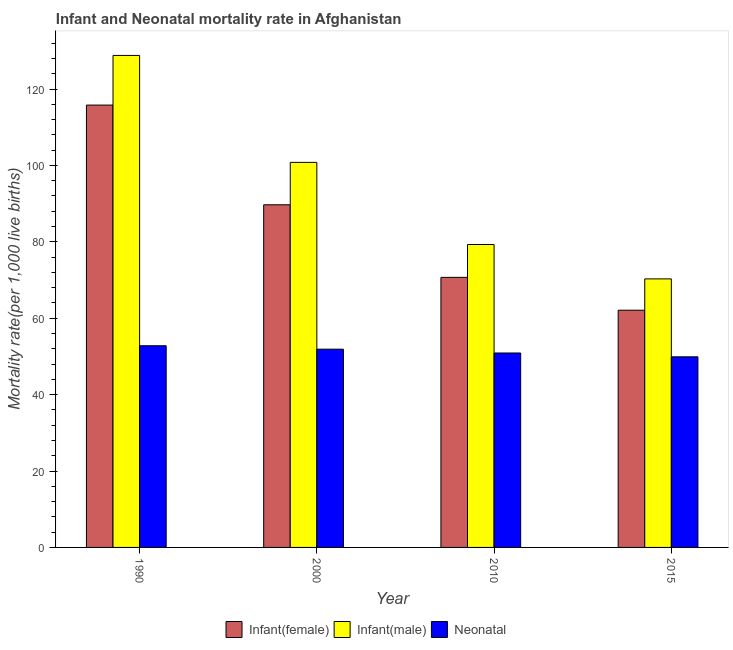How many bars are there on the 3rd tick from the right?
Your response must be concise. 3. What is the label of the 2nd group of bars from the left?
Ensure brevity in your answer.  2000. In how many cases, is the number of bars for a given year not equal to the number of legend labels?
Give a very brief answer. 0. What is the neonatal mortality rate in 2015?
Your answer should be compact. 49.9. Across all years, what is the maximum infant mortality rate(female)?
Keep it short and to the point. 115.8. Across all years, what is the minimum infant mortality rate(male)?
Keep it short and to the point. 70.3. In which year was the neonatal mortality rate maximum?
Your response must be concise. 1990. In which year was the infant mortality rate(male) minimum?
Offer a terse response. 2015. What is the total infant mortality rate(female) in the graph?
Provide a succinct answer. 338.3. What is the difference between the infant mortality rate(female) in 2010 and that in 2015?
Ensure brevity in your answer.  8.6. What is the difference between the infant mortality rate(female) in 2010 and the neonatal mortality rate in 2000?
Your answer should be very brief. -19. What is the average infant mortality rate(male) per year?
Your response must be concise. 94.8. In the year 1990, what is the difference between the infant mortality rate(female) and neonatal mortality rate?
Provide a short and direct response. 0. What is the ratio of the infant mortality rate(female) in 2000 to that in 2015?
Your response must be concise. 1.44. Is the difference between the infant mortality rate(female) in 1990 and 2000 greater than the difference between the infant mortality rate(male) in 1990 and 2000?
Offer a terse response. No. What is the difference between the highest and the second highest neonatal mortality rate?
Your answer should be compact. 0.9. What is the difference between the highest and the lowest infant mortality rate(male)?
Make the answer very short. 58.5. Is the sum of the neonatal mortality rate in 1990 and 2015 greater than the maximum infant mortality rate(female) across all years?
Ensure brevity in your answer.  Yes. What does the 3rd bar from the left in 1990 represents?
Give a very brief answer. Neonatal . What does the 2nd bar from the right in 1990 represents?
Provide a succinct answer. Infant(male). Is it the case that in every year, the sum of the infant mortality rate(female) and infant mortality rate(male) is greater than the neonatal mortality rate?
Offer a terse response. Yes. How many bars are there?
Provide a short and direct response. 12. Are all the bars in the graph horizontal?
Your response must be concise. No. What is the difference between two consecutive major ticks on the Y-axis?
Offer a very short reply. 20. Are the values on the major ticks of Y-axis written in scientific E-notation?
Make the answer very short. No. How many legend labels are there?
Give a very brief answer. 3. How are the legend labels stacked?
Offer a very short reply. Horizontal. What is the title of the graph?
Your answer should be compact. Infant and Neonatal mortality rate in Afghanistan. What is the label or title of the X-axis?
Provide a short and direct response. Year. What is the label or title of the Y-axis?
Your answer should be compact. Mortality rate(per 1,0 live births). What is the Mortality rate(per 1,000 live births) of Infant(female) in 1990?
Offer a terse response. 115.8. What is the Mortality rate(per 1,000 live births) of Infant(male) in 1990?
Provide a short and direct response. 128.8. What is the Mortality rate(per 1,000 live births) in Neonatal  in 1990?
Offer a terse response. 52.8. What is the Mortality rate(per 1,000 live births) of Infant(female) in 2000?
Your response must be concise. 89.7. What is the Mortality rate(per 1,000 live births) in Infant(male) in 2000?
Provide a succinct answer. 100.8. What is the Mortality rate(per 1,000 live births) in Neonatal  in 2000?
Your answer should be very brief. 51.9. What is the Mortality rate(per 1,000 live births) in Infant(female) in 2010?
Ensure brevity in your answer.  70.7. What is the Mortality rate(per 1,000 live births) of Infant(male) in 2010?
Provide a succinct answer. 79.3. What is the Mortality rate(per 1,000 live births) in Neonatal  in 2010?
Offer a terse response. 50.9. What is the Mortality rate(per 1,000 live births) of Infant(female) in 2015?
Offer a very short reply. 62.1. What is the Mortality rate(per 1,000 live births) in Infant(male) in 2015?
Your response must be concise. 70.3. What is the Mortality rate(per 1,000 live births) in Neonatal  in 2015?
Your response must be concise. 49.9. Across all years, what is the maximum Mortality rate(per 1,000 live births) in Infant(female)?
Your answer should be very brief. 115.8. Across all years, what is the maximum Mortality rate(per 1,000 live births) in Infant(male)?
Your answer should be compact. 128.8. Across all years, what is the maximum Mortality rate(per 1,000 live births) of Neonatal ?
Offer a very short reply. 52.8. Across all years, what is the minimum Mortality rate(per 1,000 live births) of Infant(female)?
Your response must be concise. 62.1. Across all years, what is the minimum Mortality rate(per 1,000 live births) in Infant(male)?
Offer a very short reply. 70.3. Across all years, what is the minimum Mortality rate(per 1,000 live births) in Neonatal ?
Offer a very short reply. 49.9. What is the total Mortality rate(per 1,000 live births) in Infant(female) in the graph?
Make the answer very short. 338.3. What is the total Mortality rate(per 1,000 live births) of Infant(male) in the graph?
Your answer should be compact. 379.2. What is the total Mortality rate(per 1,000 live births) of Neonatal  in the graph?
Ensure brevity in your answer.  205.5. What is the difference between the Mortality rate(per 1,000 live births) of Infant(female) in 1990 and that in 2000?
Ensure brevity in your answer.  26.1. What is the difference between the Mortality rate(per 1,000 live births) of Infant(male) in 1990 and that in 2000?
Keep it short and to the point. 28. What is the difference between the Mortality rate(per 1,000 live births) in Neonatal  in 1990 and that in 2000?
Your answer should be very brief. 0.9. What is the difference between the Mortality rate(per 1,000 live births) in Infant(female) in 1990 and that in 2010?
Keep it short and to the point. 45.1. What is the difference between the Mortality rate(per 1,000 live births) of Infant(male) in 1990 and that in 2010?
Provide a short and direct response. 49.5. What is the difference between the Mortality rate(per 1,000 live births) in Infant(female) in 1990 and that in 2015?
Your answer should be very brief. 53.7. What is the difference between the Mortality rate(per 1,000 live births) of Infant(male) in 1990 and that in 2015?
Offer a very short reply. 58.5. What is the difference between the Mortality rate(per 1,000 live births) in Neonatal  in 1990 and that in 2015?
Your answer should be compact. 2.9. What is the difference between the Mortality rate(per 1,000 live births) in Infant(female) in 2000 and that in 2010?
Offer a very short reply. 19. What is the difference between the Mortality rate(per 1,000 live births) in Infant(male) in 2000 and that in 2010?
Keep it short and to the point. 21.5. What is the difference between the Mortality rate(per 1,000 live births) in Infant(female) in 2000 and that in 2015?
Your answer should be very brief. 27.6. What is the difference between the Mortality rate(per 1,000 live births) of Infant(male) in 2000 and that in 2015?
Ensure brevity in your answer.  30.5. What is the difference between the Mortality rate(per 1,000 live births) of Neonatal  in 2000 and that in 2015?
Provide a short and direct response. 2. What is the difference between the Mortality rate(per 1,000 live births) of Infant(female) in 1990 and the Mortality rate(per 1,000 live births) of Neonatal  in 2000?
Your answer should be very brief. 63.9. What is the difference between the Mortality rate(per 1,000 live births) of Infant(male) in 1990 and the Mortality rate(per 1,000 live births) of Neonatal  in 2000?
Provide a short and direct response. 76.9. What is the difference between the Mortality rate(per 1,000 live births) in Infant(female) in 1990 and the Mortality rate(per 1,000 live births) in Infant(male) in 2010?
Offer a very short reply. 36.5. What is the difference between the Mortality rate(per 1,000 live births) of Infant(female) in 1990 and the Mortality rate(per 1,000 live births) of Neonatal  in 2010?
Provide a short and direct response. 64.9. What is the difference between the Mortality rate(per 1,000 live births) of Infant(male) in 1990 and the Mortality rate(per 1,000 live births) of Neonatal  in 2010?
Your answer should be compact. 77.9. What is the difference between the Mortality rate(per 1,000 live births) in Infant(female) in 1990 and the Mortality rate(per 1,000 live births) in Infant(male) in 2015?
Provide a succinct answer. 45.5. What is the difference between the Mortality rate(per 1,000 live births) of Infant(female) in 1990 and the Mortality rate(per 1,000 live births) of Neonatal  in 2015?
Ensure brevity in your answer.  65.9. What is the difference between the Mortality rate(per 1,000 live births) in Infant(male) in 1990 and the Mortality rate(per 1,000 live births) in Neonatal  in 2015?
Provide a short and direct response. 78.9. What is the difference between the Mortality rate(per 1,000 live births) of Infant(female) in 2000 and the Mortality rate(per 1,000 live births) of Infant(male) in 2010?
Your answer should be very brief. 10.4. What is the difference between the Mortality rate(per 1,000 live births) in Infant(female) in 2000 and the Mortality rate(per 1,000 live births) in Neonatal  in 2010?
Your answer should be compact. 38.8. What is the difference between the Mortality rate(per 1,000 live births) in Infant(male) in 2000 and the Mortality rate(per 1,000 live births) in Neonatal  in 2010?
Your response must be concise. 49.9. What is the difference between the Mortality rate(per 1,000 live births) in Infant(female) in 2000 and the Mortality rate(per 1,000 live births) in Infant(male) in 2015?
Your answer should be very brief. 19.4. What is the difference between the Mortality rate(per 1,000 live births) in Infant(female) in 2000 and the Mortality rate(per 1,000 live births) in Neonatal  in 2015?
Keep it short and to the point. 39.8. What is the difference between the Mortality rate(per 1,000 live births) in Infant(male) in 2000 and the Mortality rate(per 1,000 live births) in Neonatal  in 2015?
Offer a terse response. 50.9. What is the difference between the Mortality rate(per 1,000 live births) in Infant(female) in 2010 and the Mortality rate(per 1,000 live births) in Infant(male) in 2015?
Ensure brevity in your answer.  0.4. What is the difference between the Mortality rate(per 1,000 live births) of Infant(female) in 2010 and the Mortality rate(per 1,000 live births) of Neonatal  in 2015?
Offer a terse response. 20.8. What is the difference between the Mortality rate(per 1,000 live births) of Infant(male) in 2010 and the Mortality rate(per 1,000 live births) of Neonatal  in 2015?
Offer a terse response. 29.4. What is the average Mortality rate(per 1,000 live births) of Infant(female) per year?
Provide a short and direct response. 84.58. What is the average Mortality rate(per 1,000 live births) in Infant(male) per year?
Make the answer very short. 94.8. What is the average Mortality rate(per 1,000 live births) of Neonatal  per year?
Offer a very short reply. 51.38. In the year 1990, what is the difference between the Mortality rate(per 1,000 live births) of Infant(female) and Mortality rate(per 1,000 live births) of Neonatal ?
Keep it short and to the point. 63. In the year 1990, what is the difference between the Mortality rate(per 1,000 live births) of Infant(male) and Mortality rate(per 1,000 live births) of Neonatal ?
Your response must be concise. 76. In the year 2000, what is the difference between the Mortality rate(per 1,000 live births) in Infant(female) and Mortality rate(per 1,000 live births) in Infant(male)?
Make the answer very short. -11.1. In the year 2000, what is the difference between the Mortality rate(per 1,000 live births) of Infant(female) and Mortality rate(per 1,000 live births) of Neonatal ?
Provide a succinct answer. 37.8. In the year 2000, what is the difference between the Mortality rate(per 1,000 live births) of Infant(male) and Mortality rate(per 1,000 live births) of Neonatal ?
Offer a terse response. 48.9. In the year 2010, what is the difference between the Mortality rate(per 1,000 live births) of Infant(female) and Mortality rate(per 1,000 live births) of Neonatal ?
Keep it short and to the point. 19.8. In the year 2010, what is the difference between the Mortality rate(per 1,000 live births) of Infant(male) and Mortality rate(per 1,000 live births) of Neonatal ?
Give a very brief answer. 28.4. In the year 2015, what is the difference between the Mortality rate(per 1,000 live births) in Infant(female) and Mortality rate(per 1,000 live births) in Neonatal ?
Make the answer very short. 12.2. In the year 2015, what is the difference between the Mortality rate(per 1,000 live births) in Infant(male) and Mortality rate(per 1,000 live births) in Neonatal ?
Offer a very short reply. 20.4. What is the ratio of the Mortality rate(per 1,000 live births) in Infant(female) in 1990 to that in 2000?
Give a very brief answer. 1.29. What is the ratio of the Mortality rate(per 1,000 live births) in Infant(male) in 1990 to that in 2000?
Your answer should be compact. 1.28. What is the ratio of the Mortality rate(per 1,000 live births) of Neonatal  in 1990 to that in 2000?
Your answer should be very brief. 1.02. What is the ratio of the Mortality rate(per 1,000 live births) in Infant(female) in 1990 to that in 2010?
Provide a short and direct response. 1.64. What is the ratio of the Mortality rate(per 1,000 live births) in Infant(male) in 1990 to that in 2010?
Give a very brief answer. 1.62. What is the ratio of the Mortality rate(per 1,000 live births) in Neonatal  in 1990 to that in 2010?
Provide a succinct answer. 1.04. What is the ratio of the Mortality rate(per 1,000 live births) in Infant(female) in 1990 to that in 2015?
Make the answer very short. 1.86. What is the ratio of the Mortality rate(per 1,000 live births) of Infant(male) in 1990 to that in 2015?
Your answer should be very brief. 1.83. What is the ratio of the Mortality rate(per 1,000 live births) of Neonatal  in 1990 to that in 2015?
Your answer should be compact. 1.06. What is the ratio of the Mortality rate(per 1,000 live births) in Infant(female) in 2000 to that in 2010?
Offer a terse response. 1.27. What is the ratio of the Mortality rate(per 1,000 live births) of Infant(male) in 2000 to that in 2010?
Your response must be concise. 1.27. What is the ratio of the Mortality rate(per 1,000 live births) in Neonatal  in 2000 to that in 2010?
Your response must be concise. 1.02. What is the ratio of the Mortality rate(per 1,000 live births) in Infant(female) in 2000 to that in 2015?
Your response must be concise. 1.44. What is the ratio of the Mortality rate(per 1,000 live births) in Infant(male) in 2000 to that in 2015?
Offer a terse response. 1.43. What is the ratio of the Mortality rate(per 1,000 live births) of Neonatal  in 2000 to that in 2015?
Make the answer very short. 1.04. What is the ratio of the Mortality rate(per 1,000 live births) of Infant(female) in 2010 to that in 2015?
Offer a very short reply. 1.14. What is the ratio of the Mortality rate(per 1,000 live births) of Infant(male) in 2010 to that in 2015?
Make the answer very short. 1.13. What is the ratio of the Mortality rate(per 1,000 live births) in Neonatal  in 2010 to that in 2015?
Your response must be concise. 1.02. What is the difference between the highest and the second highest Mortality rate(per 1,000 live births) of Infant(female)?
Offer a terse response. 26.1. What is the difference between the highest and the lowest Mortality rate(per 1,000 live births) of Infant(female)?
Ensure brevity in your answer.  53.7. What is the difference between the highest and the lowest Mortality rate(per 1,000 live births) of Infant(male)?
Keep it short and to the point. 58.5. What is the difference between the highest and the lowest Mortality rate(per 1,000 live births) in Neonatal ?
Provide a short and direct response. 2.9. 